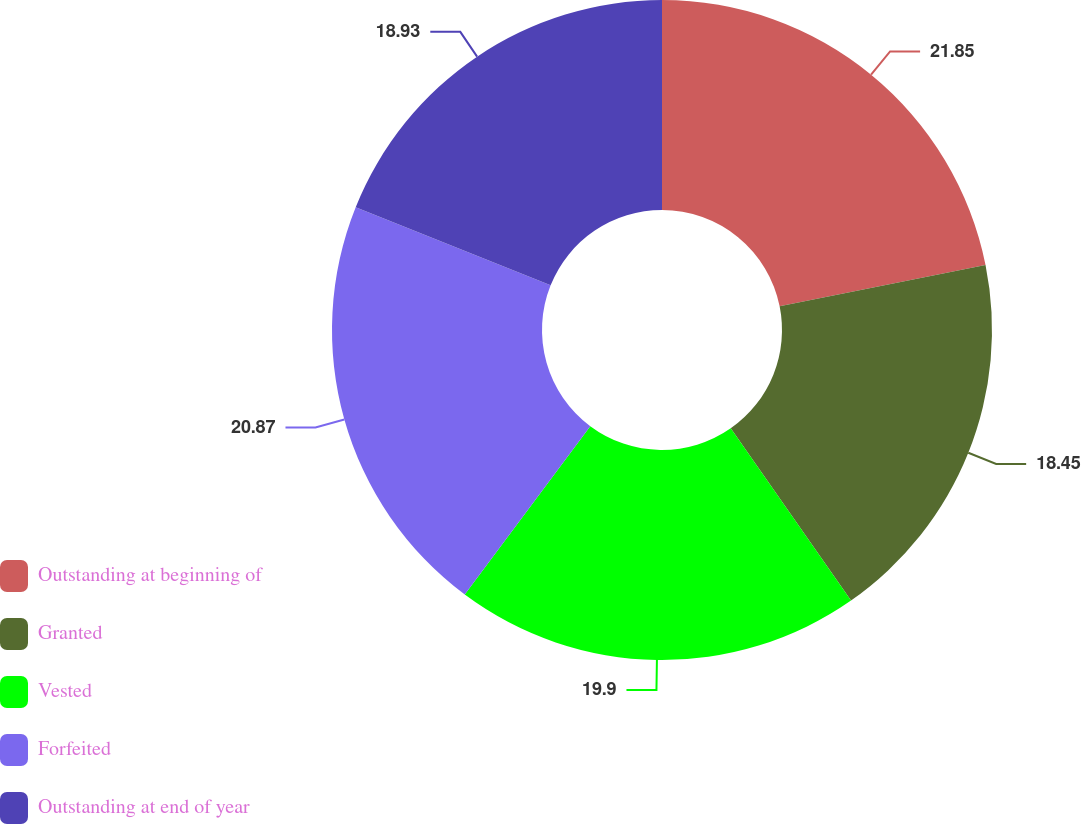Convert chart. <chart><loc_0><loc_0><loc_500><loc_500><pie_chart><fcel>Outstanding at beginning of<fcel>Granted<fcel>Vested<fcel>Forfeited<fcel>Outstanding at end of year<nl><fcel>21.84%<fcel>18.45%<fcel>19.9%<fcel>20.87%<fcel>18.93%<nl></chart> 